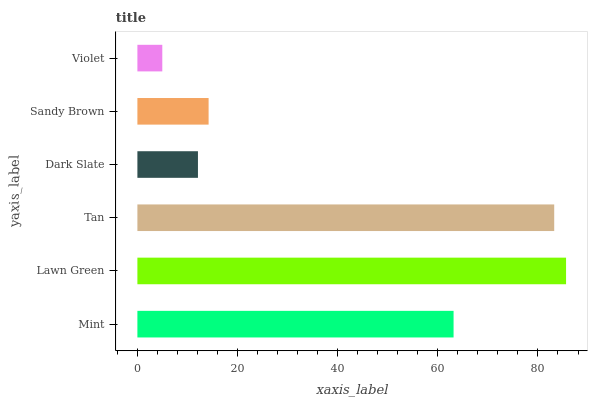Is Violet the minimum?
Answer yes or no. Yes. Is Lawn Green the maximum?
Answer yes or no. Yes. Is Tan the minimum?
Answer yes or no. No. Is Tan the maximum?
Answer yes or no. No. Is Lawn Green greater than Tan?
Answer yes or no. Yes. Is Tan less than Lawn Green?
Answer yes or no. Yes. Is Tan greater than Lawn Green?
Answer yes or no. No. Is Lawn Green less than Tan?
Answer yes or no. No. Is Mint the high median?
Answer yes or no. Yes. Is Sandy Brown the low median?
Answer yes or no. Yes. Is Dark Slate the high median?
Answer yes or no. No. Is Violet the low median?
Answer yes or no. No. 